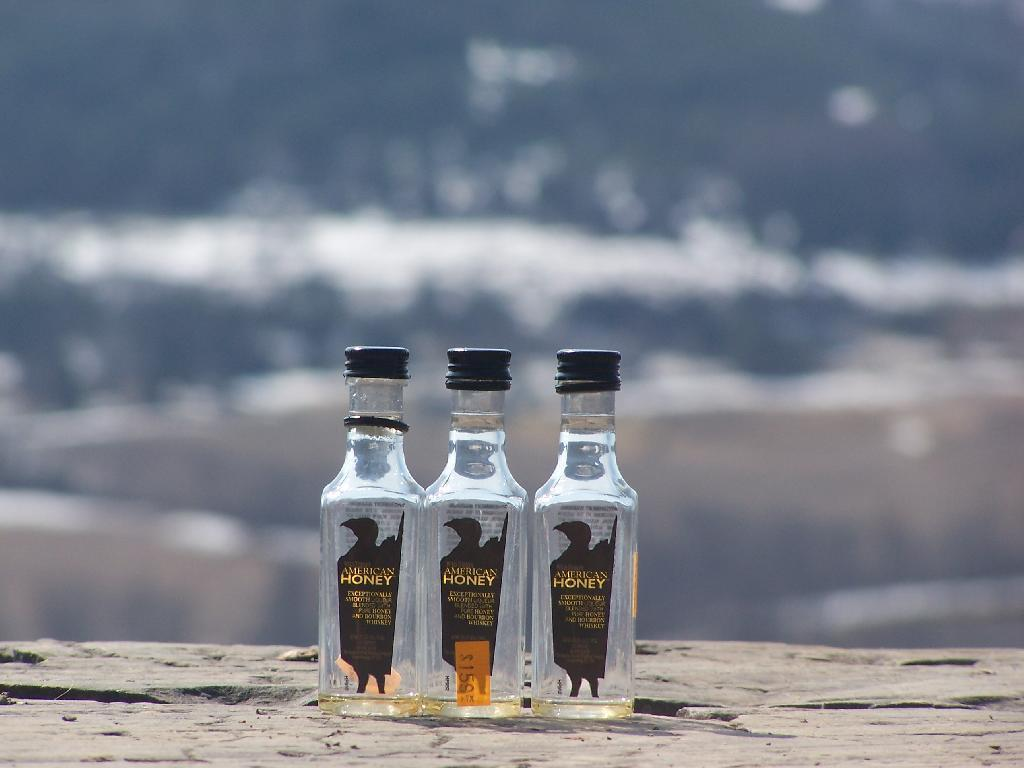<image>
Describe the image concisely. The empty bottles of American honey with lids on 